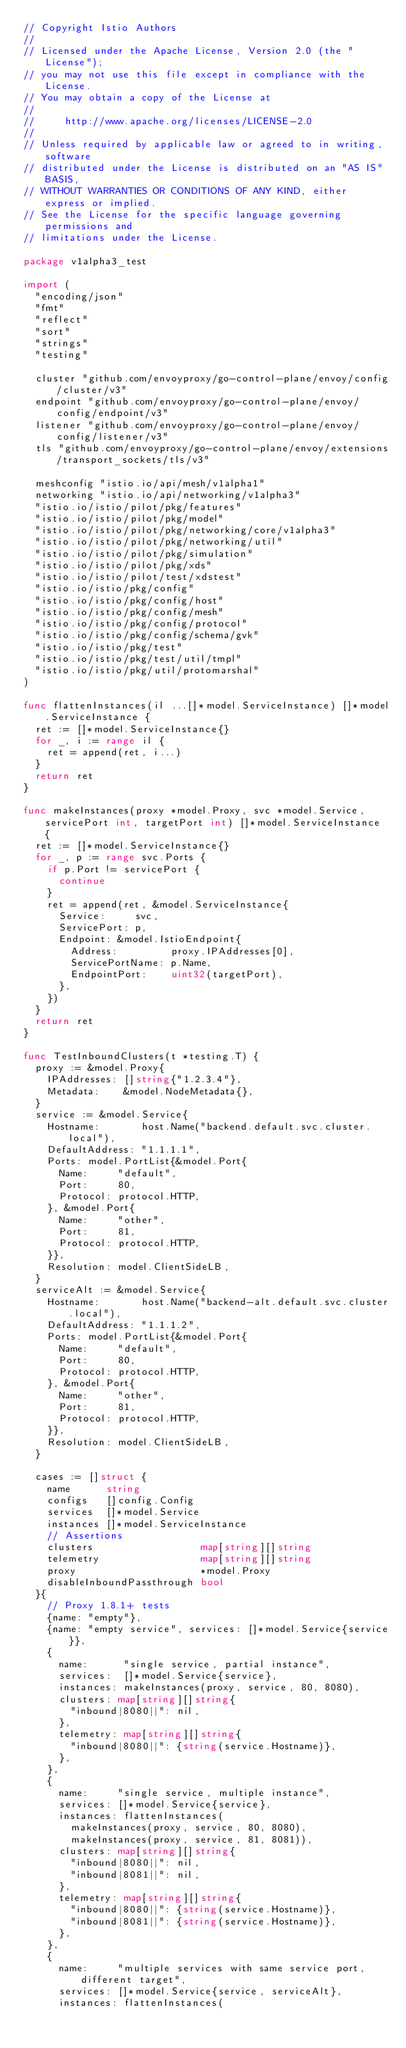Convert code to text. <code><loc_0><loc_0><loc_500><loc_500><_Go_>// Copyright Istio Authors
//
// Licensed under the Apache License, Version 2.0 (the "License");
// you may not use this file except in compliance with the License.
// You may obtain a copy of the License at
//
//     http://www.apache.org/licenses/LICENSE-2.0
//
// Unless required by applicable law or agreed to in writing, software
// distributed under the License is distributed on an "AS IS" BASIS,
// WITHOUT WARRANTIES OR CONDITIONS OF ANY KIND, either express or implied.
// See the License for the specific language governing permissions and
// limitations under the License.

package v1alpha3_test

import (
	"encoding/json"
	"fmt"
	"reflect"
	"sort"
	"strings"
	"testing"

	cluster "github.com/envoyproxy/go-control-plane/envoy/config/cluster/v3"
	endpoint "github.com/envoyproxy/go-control-plane/envoy/config/endpoint/v3"
	listener "github.com/envoyproxy/go-control-plane/envoy/config/listener/v3"
	tls "github.com/envoyproxy/go-control-plane/envoy/extensions/transport_sockets/tls/v3"

	meshconfig "istio.io/api/mesh/v1alpha1"
	networking "istio.io/api/networking/v1alpha3"
	"istio.io/istio/pilot/pkg/features"
	"istio.io/istio/pilot/pkg/model"
	"istio.io/istio/pilot/pkg/networking/core/v1alpha3"
	"istio.io/istio/pilot/pkg/networking/util"
	"istio.io/istio/pilot/pkg/simulation"
	"istio.io/istio/pilot/pkg/xds"
	"istio.io/istio/pilot/test/xdstest"
	"istio.io/istio/pkg/config"
	"istio.io/istio/pkg/config/host"
	"istio.io/istio/pkg/config/mesh"
	"istio.io/istio/pkg/config/protocol"
	"istio.io/istio/pkg/config/schema/gvk"
	"istio.io/istio/pkg/test"
	"istio.io/istio/pkg/test/util/tmpl"
	"istio.io/istio/pkg/util/protomarshal"
)

func flattenInstances(il ...[]*model.ServiceInstance) []*model.ServiceInstance {
	ret := []*model.ServiceInstance{}
	for _, i := range il {
		ret = append(ret, i...)
	}
	return ret
}

func makeInstances(proxy *model.Proxy, svc *model.Service, servicePort int, targetPort int) []*model.ServiceInstance {
	ret := []*model.ServiceInstance{}
	for _, p := range svc.Ports {
		if p.Port != servicePort {
			continue
		}
		ret = append(ret, &model.ServiceInstance{
			Service:     svc,
			ServicePort: p,
			Endpoint: &model.IstioEndpoint{
				Address:         proxy.IPAddresses[0],
				ServicePortName: p.Name,
				EndpointPort:    uint32(targetPort),
			},
		})
	}
	return ret
}

func TestInboundClusters(t *testing.T) {
	proxy := &model.Proxy{
		IPAddresses: []string{"1.2.3.4"},
		Metadata:    &model.NodeMetadata{},
	}
	service := &model.Service{
		Hostname:       host.Name("backend.default.svc.cluster.local"),
		DefaultAddress: "1.1.1.1",
		Ports: model.PortList{&model.Port{
			Name:     "default",
			Port:     80,
			Protocol: protocol.HTTP,
		}, &model.Port{
			Name:     "other",
			Port:     81,
			Protocol: protocol.HTTP,
		}},
		Resolution: model.ClientSideLB,
	}
	serviceAlt := &model.Service{
		Hostname:       host.Name("backend-alt.default.svc.cluster.local"),
		DefaultAddress: "1.1.1.2",
		Ports: model.PortList{&model.Port{
			Name:     "default",
			Port:     80,
			Protocol: protocol.HTTP,
		}, &model.Port{
			Name:     "other",
			Port:     81,
			Protocol: protocol.HTTP,
		}},
		Resolution: model.ClientSideLB,
	}

	cases := []struct {
		name      string
		configs   []config.Config
		services  []*model.Service
		instances []*model.ServiceInstance
		// Assertions
		clusters                  map[string][]string
		telemetry                 map[string][]string
		proxy                     *model.Proxy
		disableInboundPassthrough bool
	}{
		// Proxy 1.8.1+ tests
		{name: "empty"},
		{name: "empty service", services: []*model.Service{service}},
		{
			name:      "single service, partial instance",
			services:  []*model.Service{service},
			instances: makeInstances(proxy, service, 80, 8080),
			clusters: map[string][]string{
				"inbound|8080||": nil,
			},
			telemetry: map[string][]string{
				"inbound|8080||": {string(service.Hostname)},
			},
		},
		{
			name:     "single service, multiple instance",
			services: []*model.Service{service},
			instances: flattenInstances(
				makeInstances(proxy, service, 80, 8080),
				makeInstances(proxy, service, 81, 8081)),
			clusters: map[string][]string{
				"inbound|8080||": nil,
				"inbound|8081||": nil,
			},
			telemetry: map[string][]string{
				"inbound|8080||": {string(service.Hostname)},
				"inbound|8081||": {string(service.Hostname)},
			},
		},
		{
			name:     "multiple services with same service port, different target",
			services: []*model.Service{service, serviceAlt},
			instances: flattenInstances(</code> 